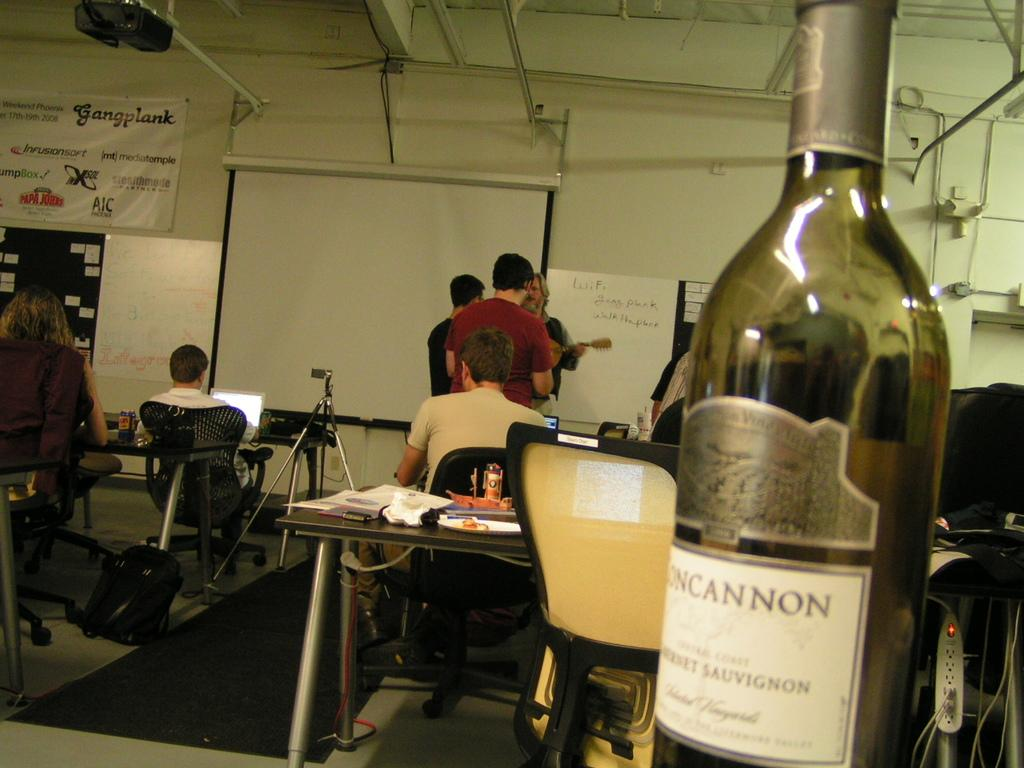<image>
Write a terse but informative summary of the picture. the word cannon that is on a wine bottle 